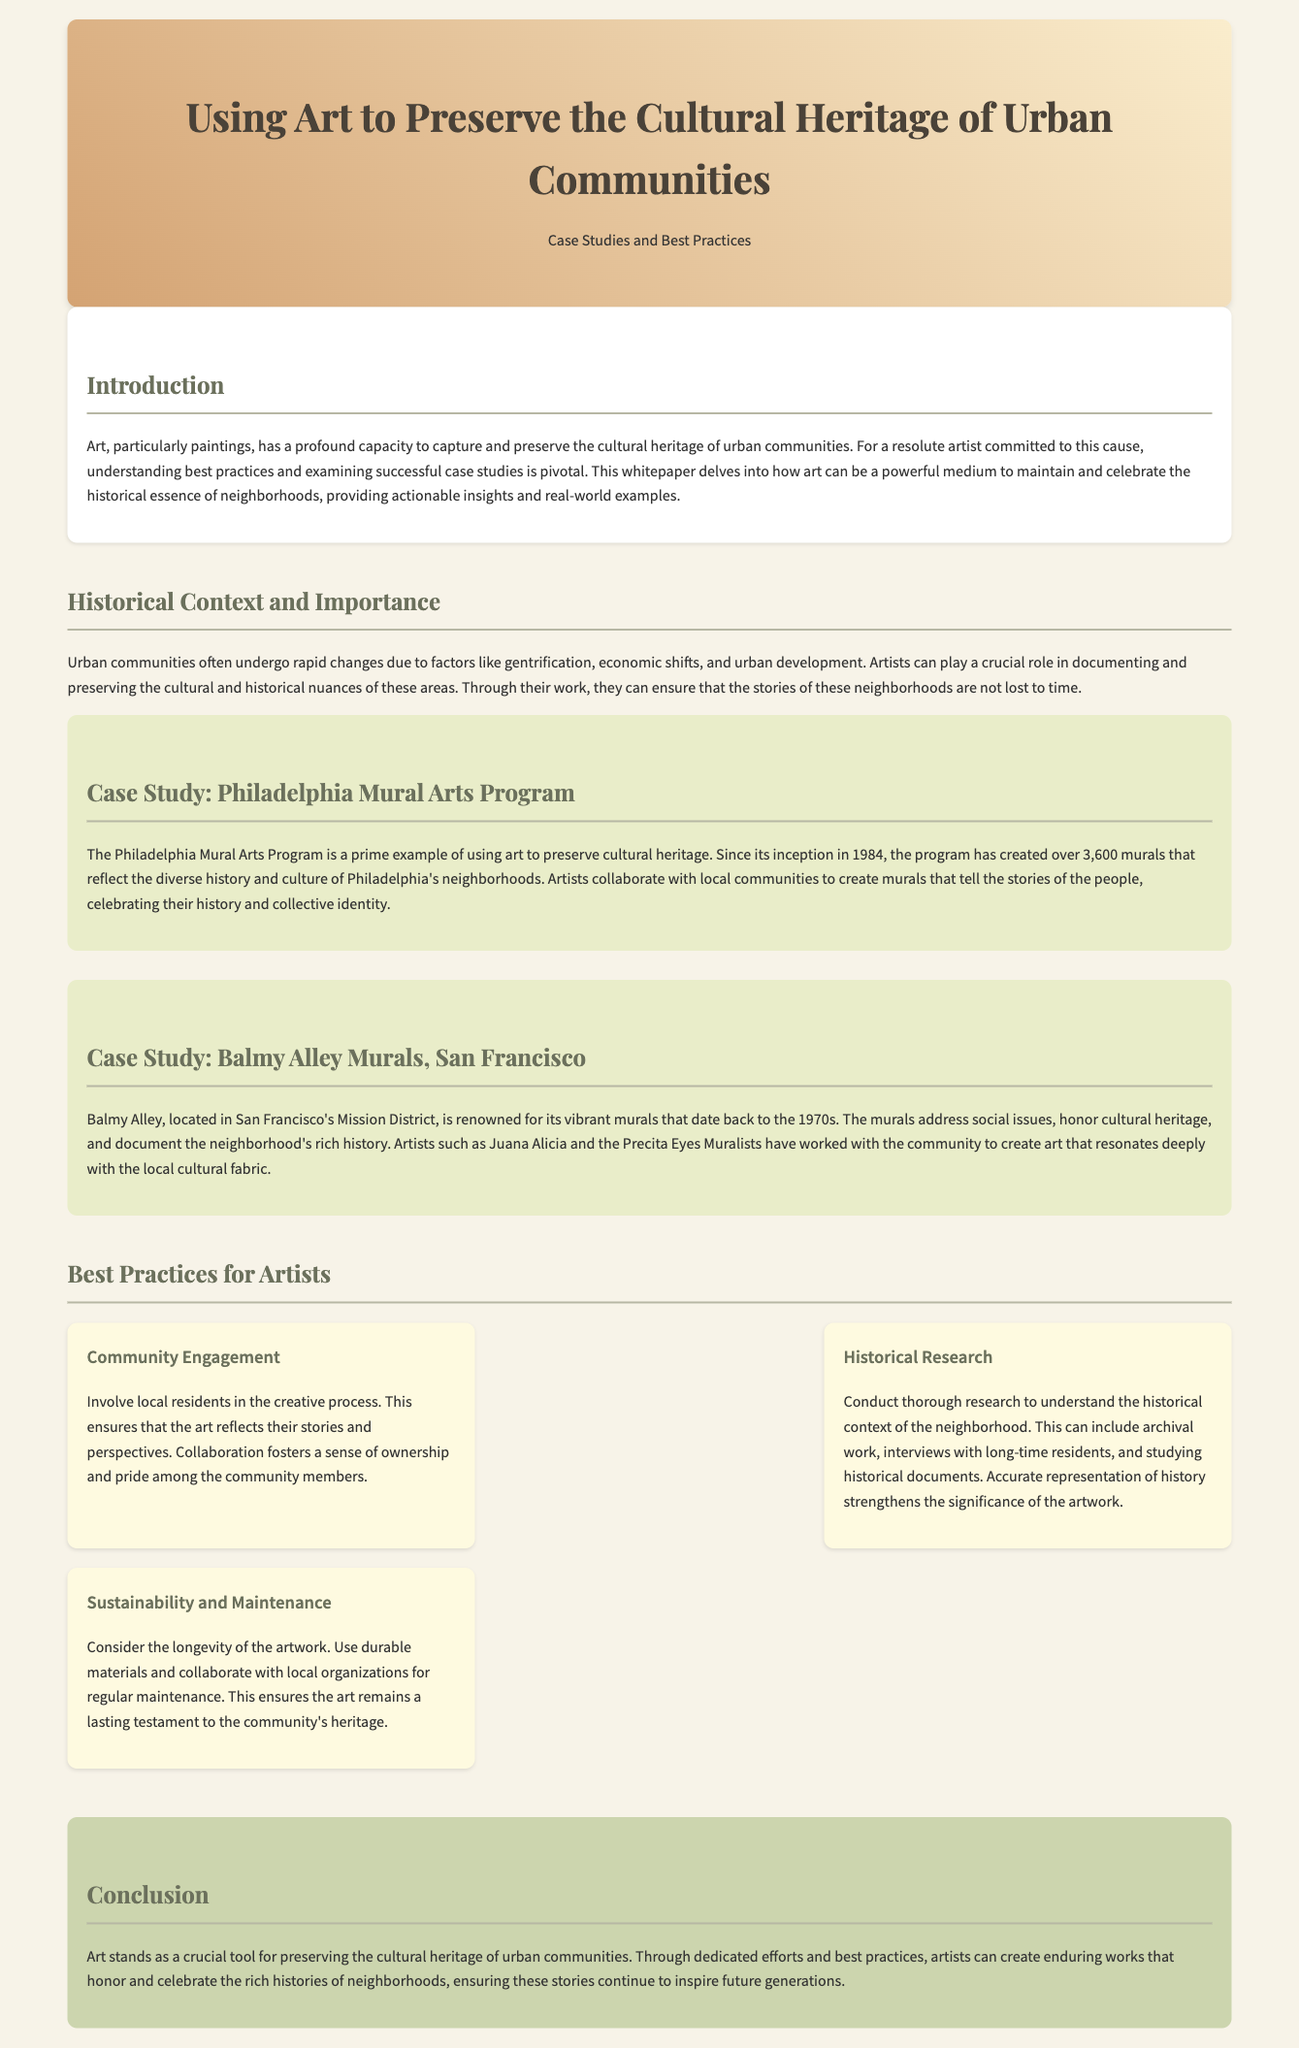what is the title of the whitepaper? The title of the whitepaper appears in the header section and reads "Using Art to Preserve the Cultural Heritage of Urban Communities".
Answer: Using Art to Preserve the Cultural Heritage of Urban Communities how many murals has the Philadelphia Mural Arts Program created? The document states that the Philadelphia Mural Arts Program has created over 3,600 murals.
Answer: over 3,600 murals what is the name of the famous alley known for its murals in San Francisco? The document mentions Balmy Alley as the well-known location for its vibrant murals in San Francisco.
Answer: Balmy Alley what is a key best practice for artists mentioned in the document? The document lists "Community Engagement" as one of the best practices for artists.
Answer: Community Engagement when was the Philadelphia Mural Arts Program founded? The document indicates that the Philadelphia Mural Arts Program was founded in 1984.
Answer: 1984 what is the focus of the Balmy Alley murals? The Balmy Alley murals focus on social issues, honor cultural heritage, and document the neighborhood's history.
Answer: social issues how does the document describe the role of artists in urban communities? The document states that artists can play a crucial role in documenting and preserving cultural and historical nuances.
Answer: crucial role which painting technique is highlighted in the best practices for sustainability? The best practices discuss using durable materials as a technique for sustainability in artwork.
Answer: durable materials what significance does art hold for urban communities according to the conclusion? The conclusion emphasizes that art is crucial for preserving the cultural heritage of urban communities.
Answer: crucial 